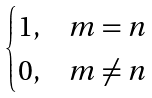<formula> <loc_0><loc_0><loc_500><loc_500>\begin{cases} 1 , & m = n \\ 0 , & m \neq n \end{cases}</formula> 